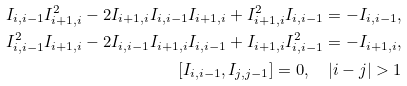Convert formula to latex. <formula><loc_0><loc_0><loc_500><loc_500>I _ { i , i - 1 } I ^ { 2 } _ { i + 1 , i } - 2 I _ { i + 1 , i } I _ { i , i - 1 } I _ { i + 1 , i } + I ^ { 2 } _ { i + 1 , i } I _ { i , i - 1 } = - I _ { i , i - 1 } , \\ I ^ { 2 } _ { i , i - 1 } I _ { i + 1 , i } - 2 I _ { i , i - 1 } I _ { i + 1 , i } I _ { i , i - 1 } + I _ { i + 1 , i } I ^ { 2 } _ { i , i - 1 } = - I _ { i + 1 , i } , \\ [ I _ { i , i - 1 } , I _ { j , j - 1 } ] = 0 , \quad | i - j | > 1</formula> 